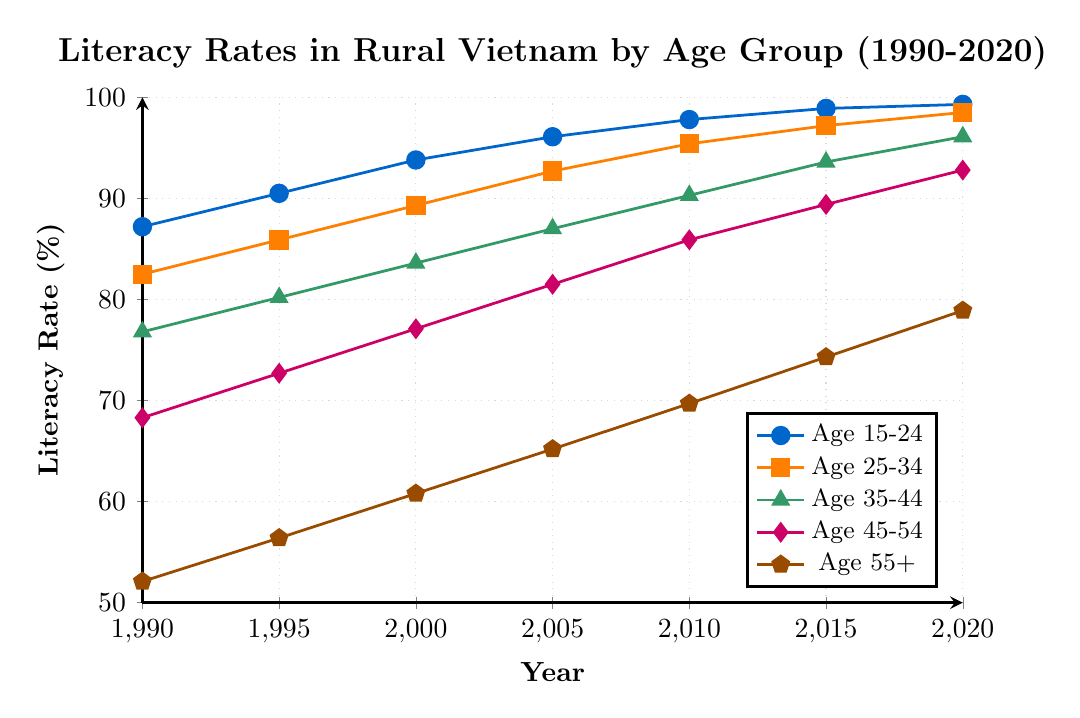What's the trend in literacy rates for the age group 15-24 between 1990 and 2020? Observe the plotted line for the age group 15-24. It starts at 87.2% in 1990 and steadily increases to 99.3% in 2020.
Answer: Increasing What is the difference in literacy rates between the age groups 15-24 and 55+ in the year 2020? The literacy rate for the age group 15-24 in 2020 is 99.3%, and for the age group 55+, it is 78.9%. Subtract 78.9 from 99.3 to get the difference.
Answer: 20.4% Which age group shows the highest literacy rate in the year 2015? Check the literacy rates for all age groups in 2015. The age group 15-24 has the highest literacy rate at 98.9%.
Answer: Age 15-24 Has the literacy rate for the age group 45-54 consistently increased from 1990 to 2020? The literacy rate for the age group 45-54 in 1990 was 68.3% and it increased consistently to 92.8% by 2020. Each data point shows a higher rate than the previous one.
Answer: Yes Which age group had the lowest literacy rate in 1990? Compare the literacy rates for all age groups in 1990. The age group 55+ had the lowest literacy rate at 52.1%.
Answer: Age 55+ How much did the literacy rate for the age group 25-34 change from 1990 to 2020? The literacy rate for the age group 25-34 was 82.5% in 1990 and 98.5% in 2020. Subtract 82.5 from 98.5 to find the change.
Answer: 16% What is the average literacy rate for the age group 35-44 across all years? Add the literacy rates for the age group 35-44 from all years and divide by the number of years: (76.8 + 80.2 + 83.6 + 87.0 + 90.3 + 93.6 + 96.1) / 7.
Answer: 86.8% How does the literacy rate of the age group 45-54 in 2000 compare to that in 2010? In 2000, the literacy rate for the age group 45-54 was 77.1%, and in 2010 it was 85.9%. The rate in 2010 is higher than in 2000.
Answer: Higher Among the age groups, which one shows the most significant increase in literacy rate from 1990 to 2020? Calculate the increase for each age group from 1990 to 2020 and find the highest one. 
For Age 15-24: 99.3 - 87.2 = 12.1
For Age 25-34: 98.5 - 82.5 = 16.0
For Age 35-44: 96.1 - 76.8 = 19.3
For Age 45-54: 92.8 - 68.3 = 24.5
For Age 55+: 78.9 - 52.1 = 26.8
The age group 55+ shows the most significant increase.
Answer: Age 55+ What is the median literacy rate for the age group 35-44 across all years? Order the literacy rates for the age group 35-44 and find the middle value.
Ordered: [76.8, 80.2, 83.6, 87.0, 90.3, 93.6, 96.1],
The middle value (4th one) is 87.0.
Answer: 87.0% 